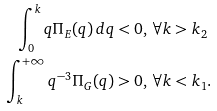<formula> <loc_0><loc_0><loc_500><loc_500>\int _ { 0 } ^ { k } q \Pi _ { E } ( q ) \, d q & < 0 , \, \forall k > k _ { 2 } \\ \int _ { k } ^ { + \infty } q ^ { - 3 } \Pi _ { G } ( q ) & > 0 , \, \forall k < k _ { 1 } .</formula> 